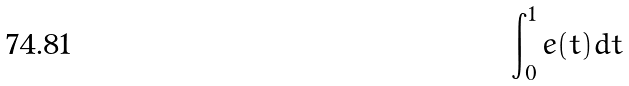Convert formula to latex. <formula><loc_0><loc_0><loc_500><loc_500>\int _ { 0 } ^ { 1 } e ( t ) d t</formula> 